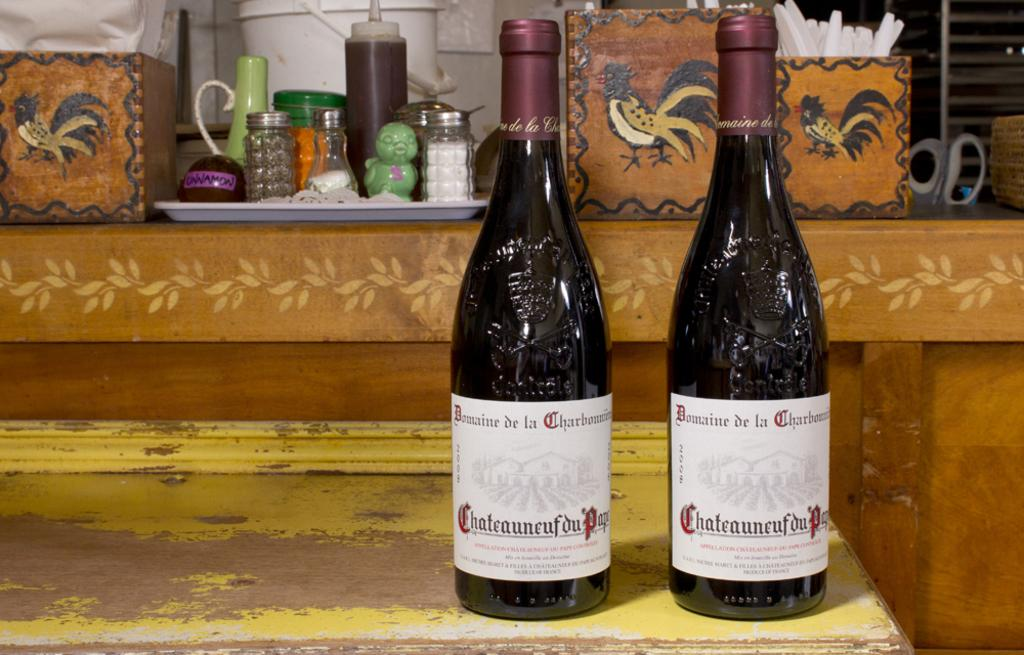<image>
Describe the image concisely. A bottle has a label that has the word Domaine on it. 